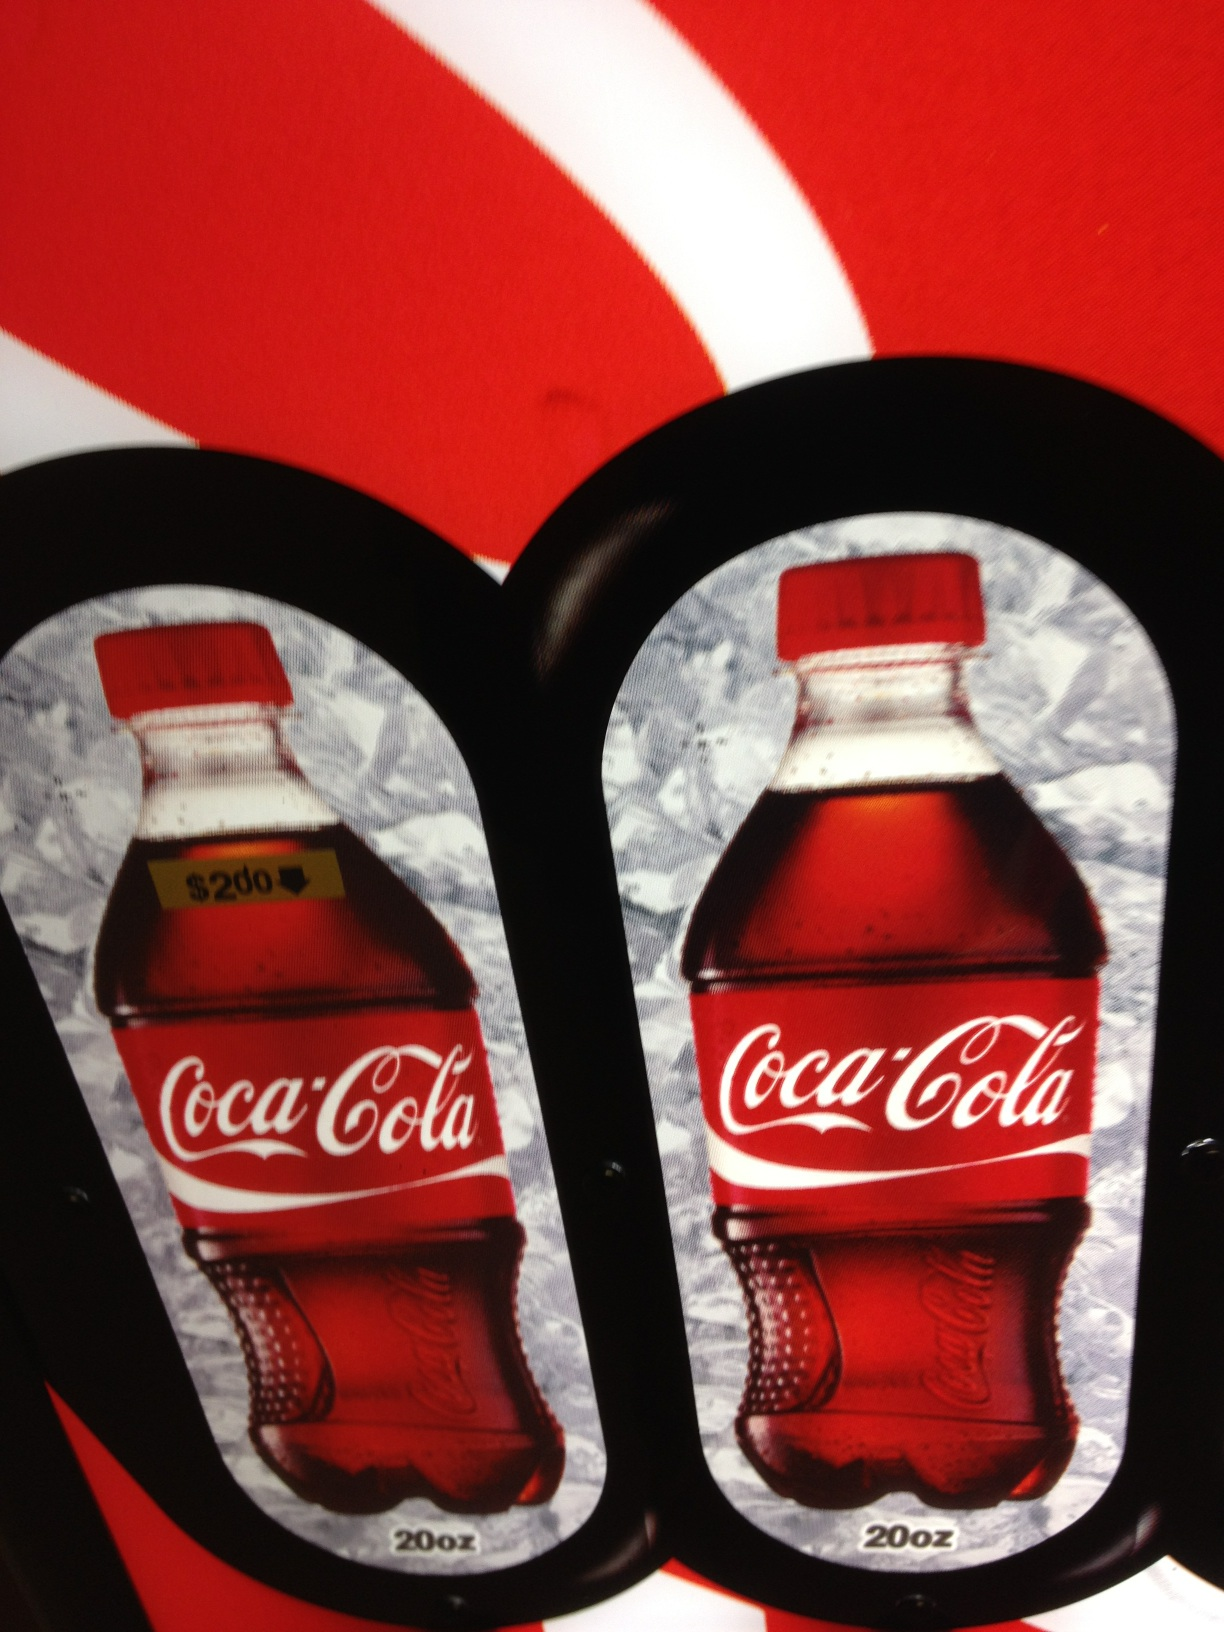What is the price shown on the Coca-Cola bottle tag? The tag on the Coca-Cola bottle shows a price of $20d, which might denote a currency format common in some regions. Is it usual for Coca-Cola to be priced like this or does it indicate a special version or region? This price likely indicates a non-standard pricing, potentially due to being a special edition, a pricing error in the image, or it being from a region with different economic conditions. Prices can vary significantly depending on these factors. 